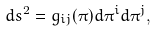Convert formula to latex. <formula><loc_0><loc_0><loc_500><loc_500>d s ^ { 2 } = g _ { i j } ( \pi ) d \pi ^ { i } d \pi ^ { j } ,</formula> 